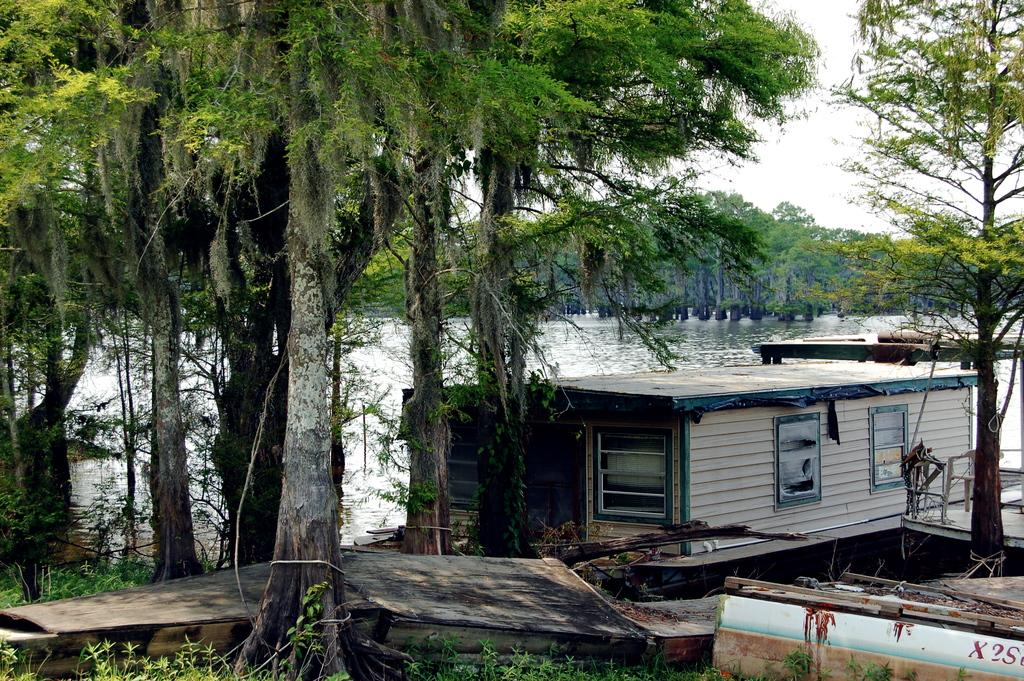What is the main subject of the picture? The main subject of the picture is a boat. Where is the boat located? The boat is on the water. What type of vegetation can be seen in the image? There are trees and grass visible in the image. What else can be seen in the image besides the boat and vegetation? There are other objects in the image. What is visible in the background of the image? The sky is visible in the background of the image. What type of quiver can be seen hanging from the boat in the image? There is no quiver present in the image; it features a boat on the water with trees, grass, and other objects visible. How many pails of water are being carried by the people in the image? There are no people or pails visible in the image. 